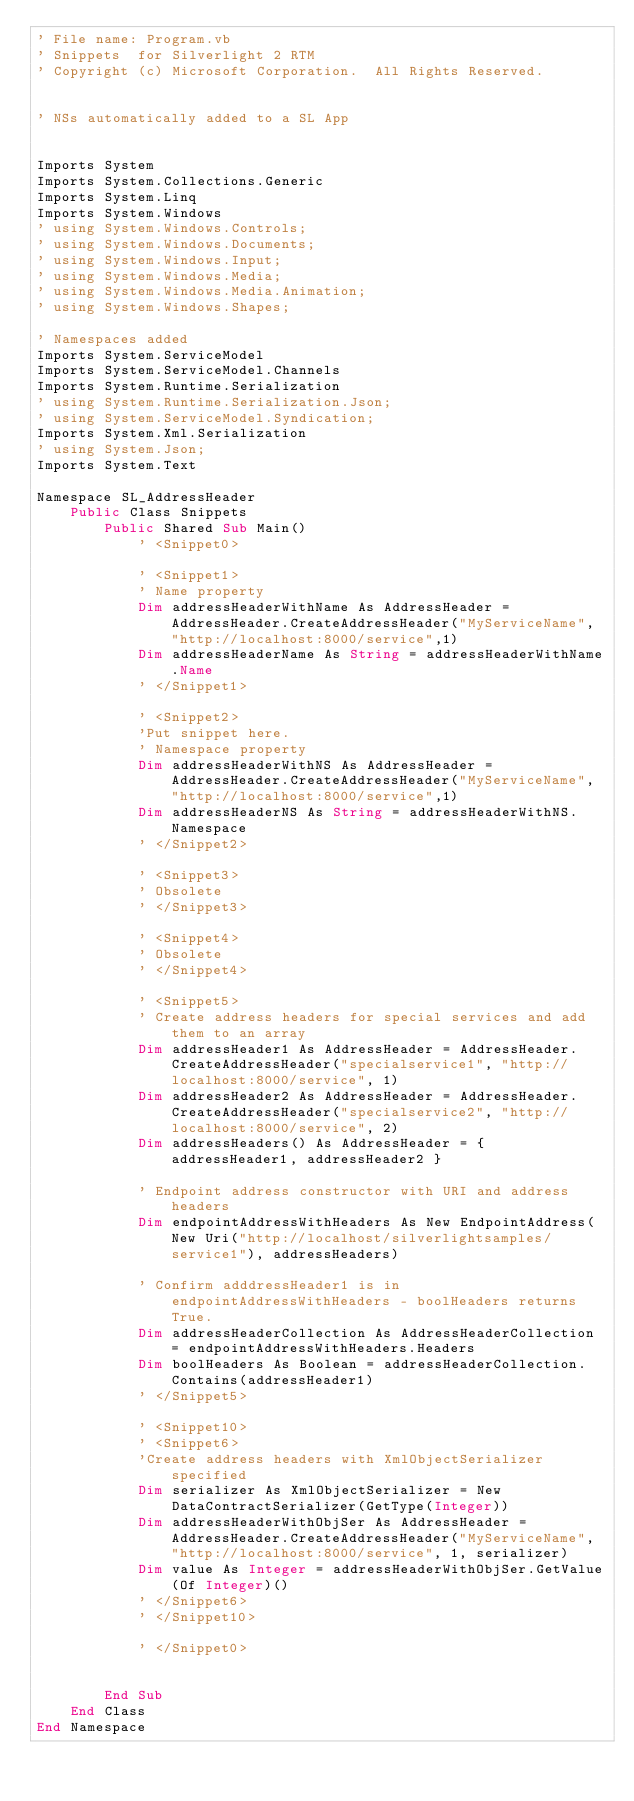Convert code to text. <code><loc_0><loc_0><loc_500><loc_500><_VisualBasic_>' File name: Program.vb
' Snippets  for Silverlight 2 RTM 
' Copyright (c) Microsoft Corporation.  All Rights Reserved.


' NSs automatically added to a SL App


Imports System
Imports System.Collections.Generic
Imports System.Linq
Imports System.Windows
' using System.Windows.Controls;
' using System.Windows.Documents;
' using System.Windows.Input;
' using System.Windows.Media;
' using System.Windows.Media.Animation;
' using System.Windows.Shapes;

' Namespaces added
Imports System.ServiceModel
Imports System.ServiceModel.Channels
Imports System.Runtime.Serialization
' using System.Runtime.Serialization.Json;
' using System.ServiceModel.Syndication;
Imports System.Xml.Serialization
' using System.Json;
Imports System.Text

Namespace SL_AddressHeader
	Public Class Snippets
		Public Shared Sub Main()
			' <Snippet0>

			' <Snippet1>
			' Name property
			Dim addressHeaderWithName As AddressHeader = AddressHeader.CreateAddressHeader("MyServiceName", "http://localhost:8000/service",1)
			Dim addressHeaderName As String = addressHeaderWithName.Name
			' </Snippet1>

			' <Snippet2>
			'Put snippet here.
			' Namespace property
			Dim addressHeaderWithNS As AddressHeader = AddressHeader.CreateAddressHeader("MyServiceName", "http://localhost:8000/service",1)
			Dim addressHeaderNS As String = addressHeaderWithNS.Namespace
			' </Snippet2>

			' <Snippet3>
			' Obsolete
			' </Snippet3>

			' <Snippet4>
			' Obsolete
			' </Snippet4>

			' <Snippet5>
			' Create address headers for special services and add them to an array
			Dim addressHeader1 As AddressHeader = AddressHeader.CreateAddressHeader("specialservice1", "http://localhost:8000/service", 1)
			Dim addressHeader2 As AddressHeader = AddressHeader.CreateAddressHeader("specialservice2", "http://localhost:8000/service", 2)
			Dim addressHeaders() As AddressHeader = { addressHeader1, addressHeader2 }

			' Endpoint address constructor with URI and address headers
			Dim endpointAddressWithHeaders As New EndpointAddress(New Uri("http://localhost/silverlightsamples/service1"), addressHeaders)

			' Confirm adddressHeader1 is in endpointAddressWithHeaders - boolHeaders returns True.
			Dim addressHeaderCollection As AddressHeaderCollection = endpointAddressWithHeaders.Headers
			Dim boolHeaders As Boolean = addressHeaderCollection.Contains(addressHeader1)
			' </Snippet5>

			' <Snippet10>
			' <Snippet6>
			'Create address headers with XmlObjectSerializer specified
			Dim serializer As XmlObjectSerializer = New DataContractSerializer(GetType(Integer))
			Dim addressHeaderWithObjSer As AddressHeader = AddressHeader.CreateAddressHeader("MyServiceName", "http://localhost:8000/service", 1, serializer)
			Dim value As Integer = addressHeaderWithObjSer.GetValue(Of Integer)()
			' </Snippet6>
			' </Snippet10>

			' </Snippet0>


		End Sub
	End Class
End Namespace</code> 